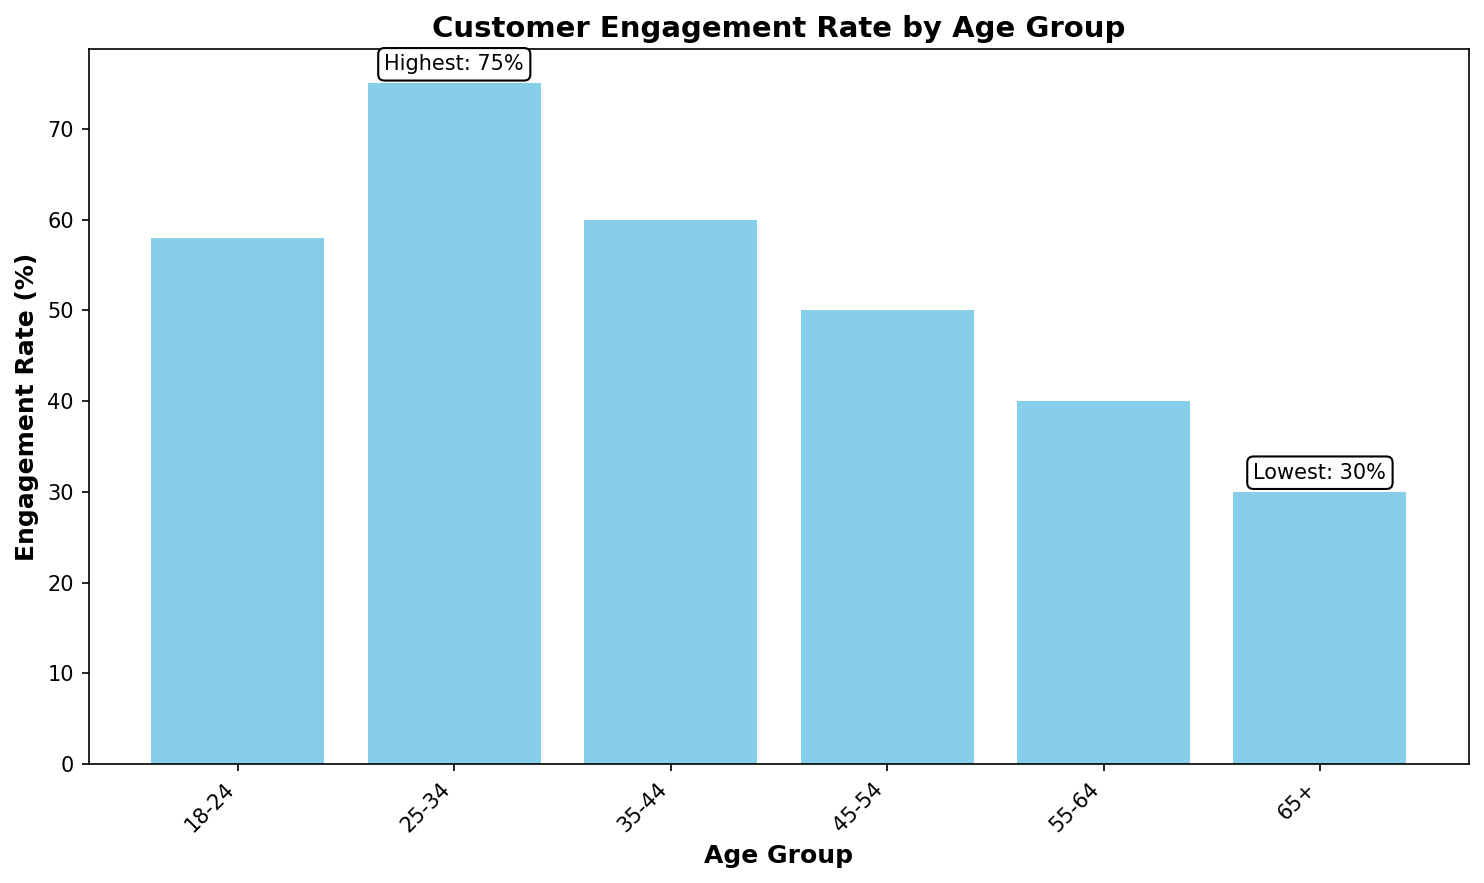How many percentage points higher is the engagement rate for the 25-34 age group compared to the 45-54 age group? First, find the engagement rates for the 25-34 and 45-54 age groups, which are 75% and 50%, respectively. Subtract the engagement rate of the 45-54 age group from that of the 25-34 age group: 75% - 50% = 25%.
Answer: 25% What is the sum of the engagement rates for the age groups under 35 years old? Add the engagement rates for the 18-24 and 25-34 age groups. The rates are 58% and 75%, respectively. 58% + 75% = 133%.
Answer: 133% Which age group has the lowest engagement rate and what is the value? Identify the age group with the lowest bar in the chart, which also has a text annotation indicating "Lowest: 30%". This is the 65+ age group.
Answer: 65+, 30% How much greater is the engagement rate of the 18-24 age group compared to the 65+ age group? The engagement rate of the 18-24 age group is 58% and that of the 65+ age group is 30%. Subtract the 65+ age group's rate from the 18-24 age group's rate: 58% - 30% = 28%.
Answer: 28% What is the average engagement rate for all age groups combined? Add all the engagement rates: 58% (18-24) + 75% (25-34) + 60% (35-44) + 50% (45-54) + 40% (55-64) + 30% (65+). The total is 313%. Divide by the number of age groups, which is 6: 313% / 6 ≈ 52.17%.
Answer: 52.17% Which two age groups have between them the second and third highest engagement rates? First, order the engagement rates: 75% (25-34), 60% (35-44), 58% (18-24), 50% (45-54), 40% (55-64), and 30% (65+). The second and third highest rates are 60% and 58% for the 35-44 and 18-24 age groups, respectively.
Answer: 35-44 and 18-24 What is the difference in percentage points between the highest and lowest engagement rates? The highest engagement rate is 75% for the 25-34 age group and the lowest engagement rate is 30% for the 65+ age group. Subtract the lowest rate from the highest rate: 75% - 30% = 45%.
Answer: 45% Which age group is right below the highlighted highest engagement rate? The highest engagement rate is 75% for the 25-34 age group. Look for the age group with the next highest engagement rate which, from the data, is 60% for the 35-44 age group.
Answer: 35-44 How many age groups have an engagement rate above the overall average? The overall average engagement rate is approximately 52.17%. The age groups with engagement rates above this average are 18-24 (58%), 25-34 (75%), and 35-44 (60%). This makes a total of 3 age groups.
Answer: 3 What trend do you observe as the age groups increase from 18-24 to 65+ in terms of engagement rate? Starting from 18-24 (58%) and increasing in age groups up to 65+ (30%), the engagement rate generally decreases. The rate peaks at 25-34 (75%) and shows a downward trend afterward.
Answer: Decreasing trend 